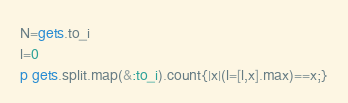<code> <loc_0><loc_0><loc_500><loc_500><_Ruby_>N=gets.to_i
l=0
p gets.split.map(&:to_i).count{|x|(l=[l,x].max)==x;}</code> 